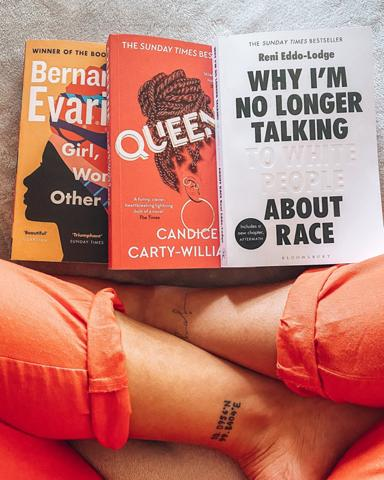Can you explain the relevance of the tattoo visible in the image in relation to the books? The tattoo, which says 'no rain, no flowers,' can symbolically resonate with the themes of the books, suggesting that growth and beauty often stem from challenges and struggles, much like the issues of race and personal identity explored in the books. 